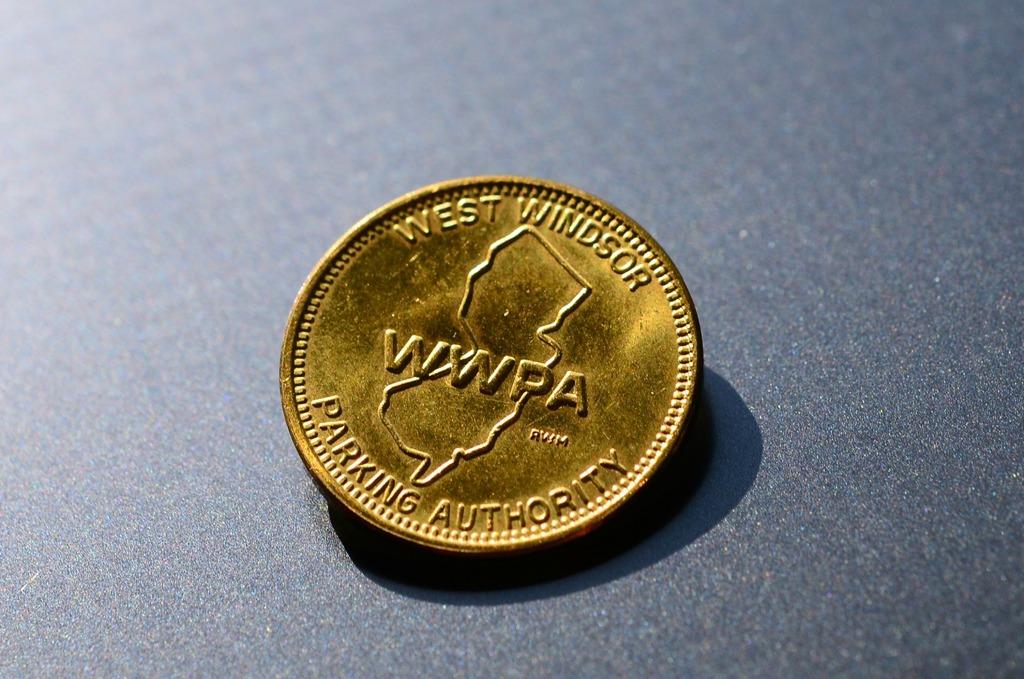Which organization issue this coin?
Your response must be concise. Wwpa. What does wwpa stand for?
Your answer should be very brief. West windsor parking authority. 